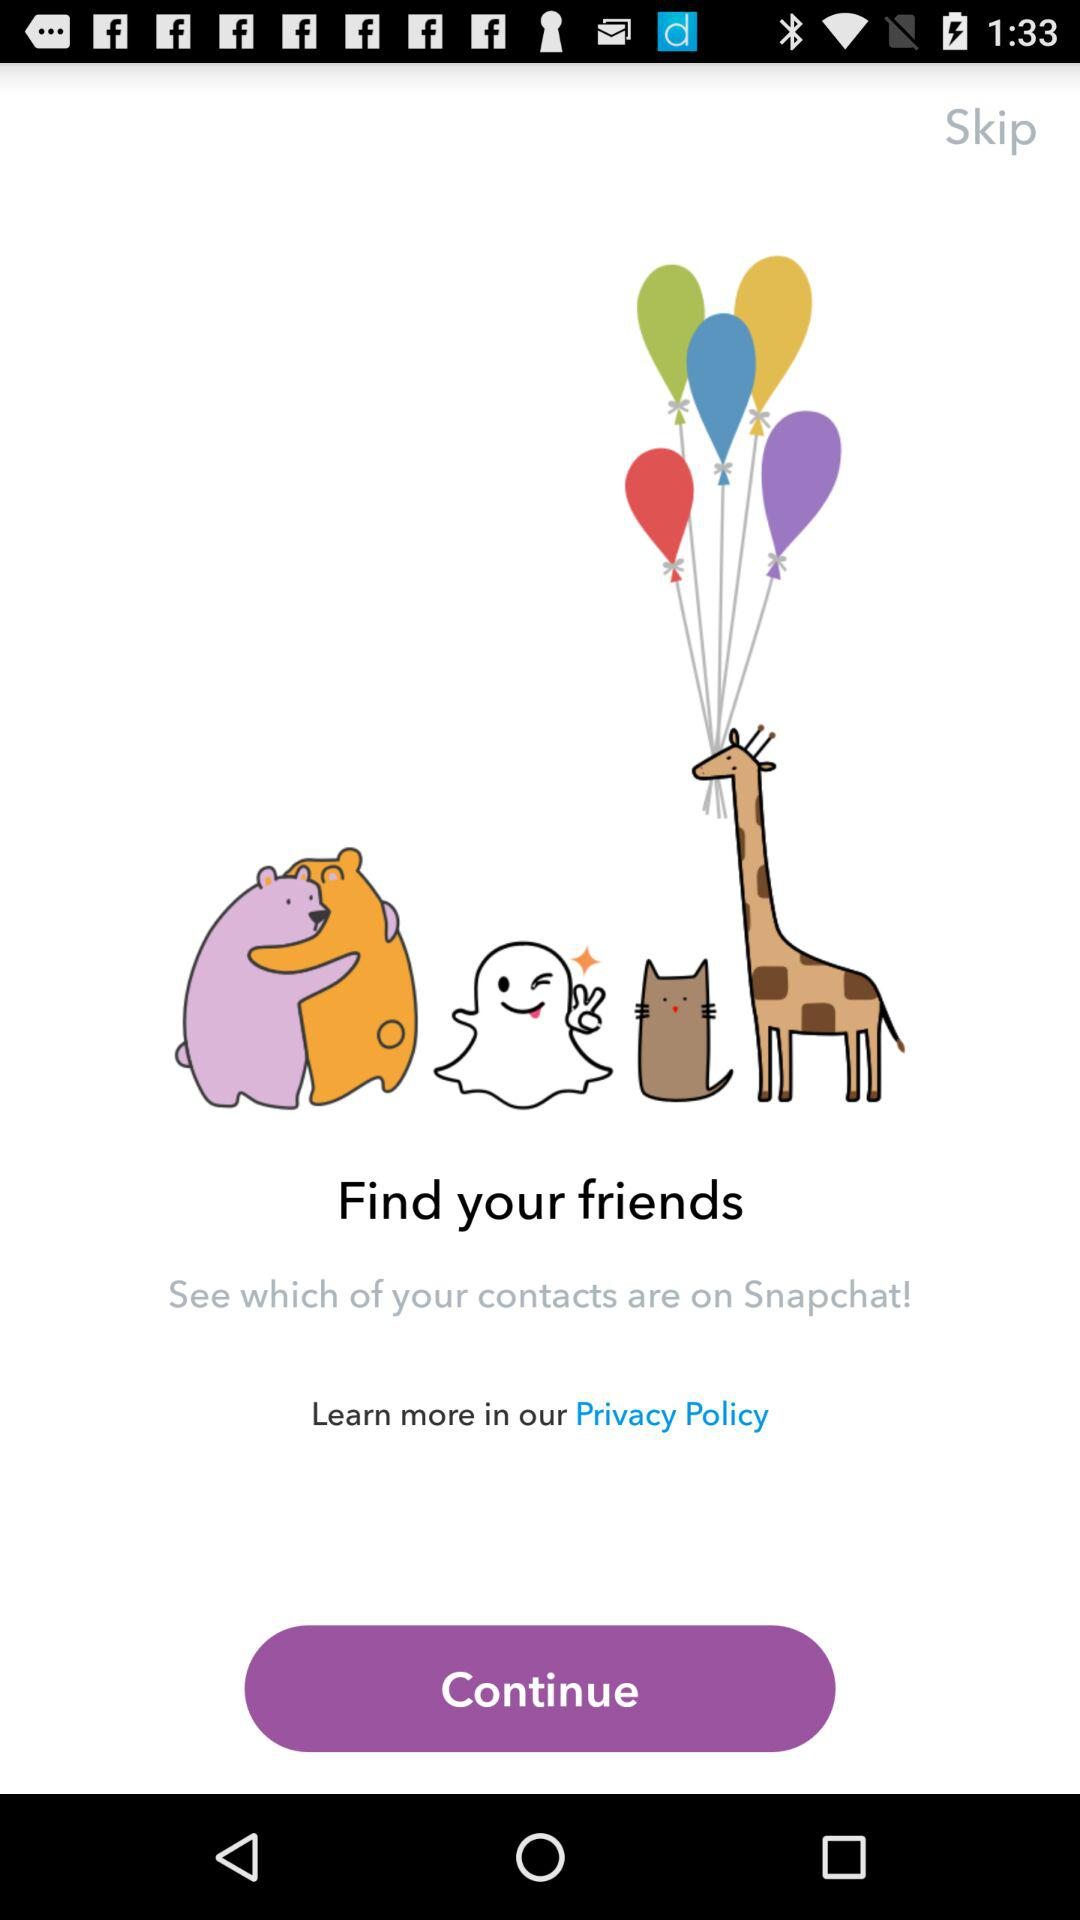What is the application name? The application name is "Snapchat!". 